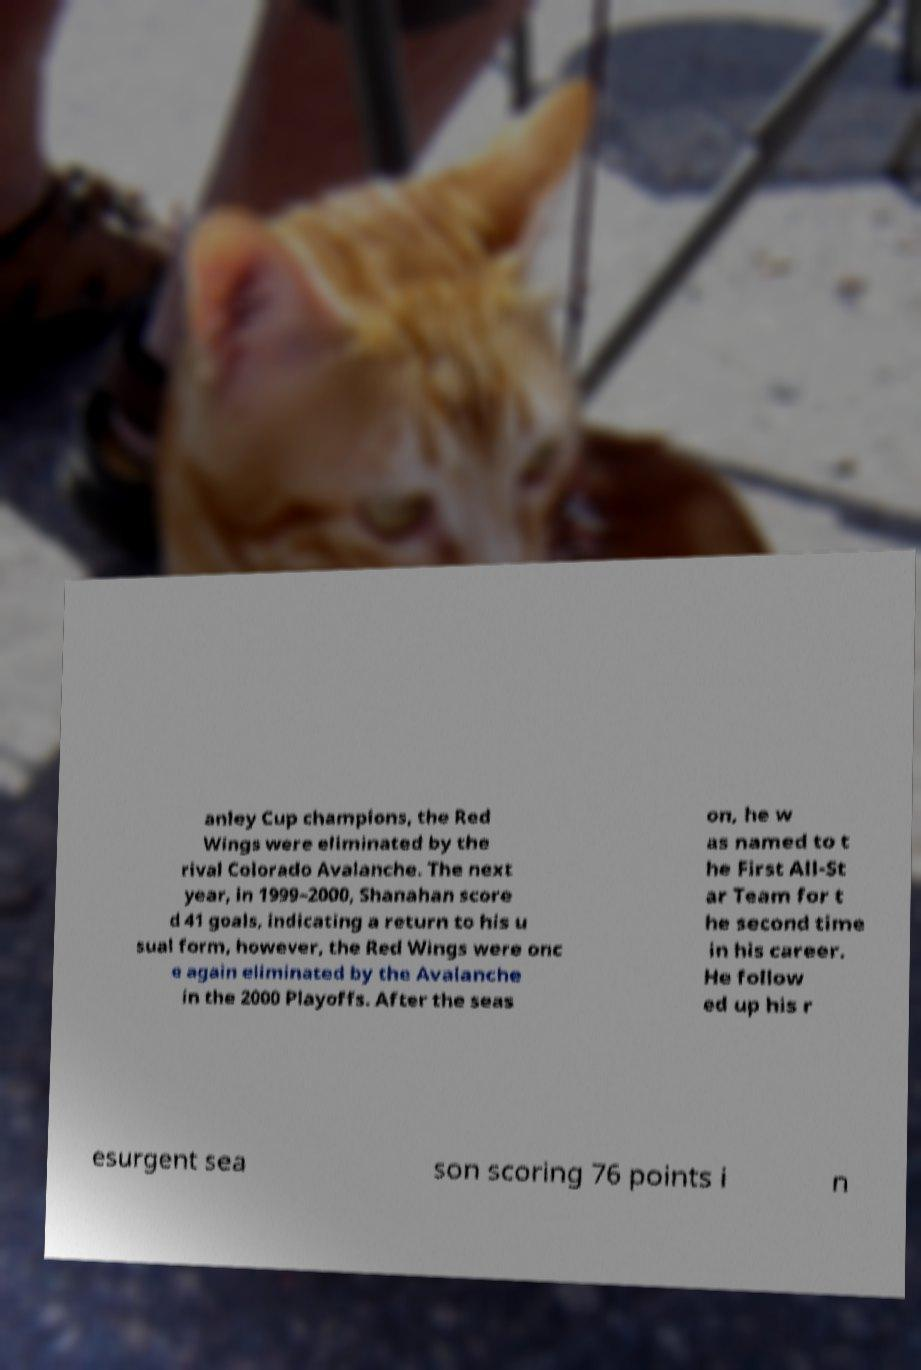Can you accurately transcribe the text from the provided image for me? anley Cup champions, the Red Wings were eliminated by the rival Colorado Avalanche. The next year, in 1999–2000, Shanahan score d 41 goals, indicating a return to his u sual form, however, the Red Wings were onc e again eliminated by the Avalanche in the 2000 Playoffs. After the seas on, he w as named to t he First All-St ar Team for t he second time in his career. He follow ed up his r esurgent sea son scoring 76 points i n 